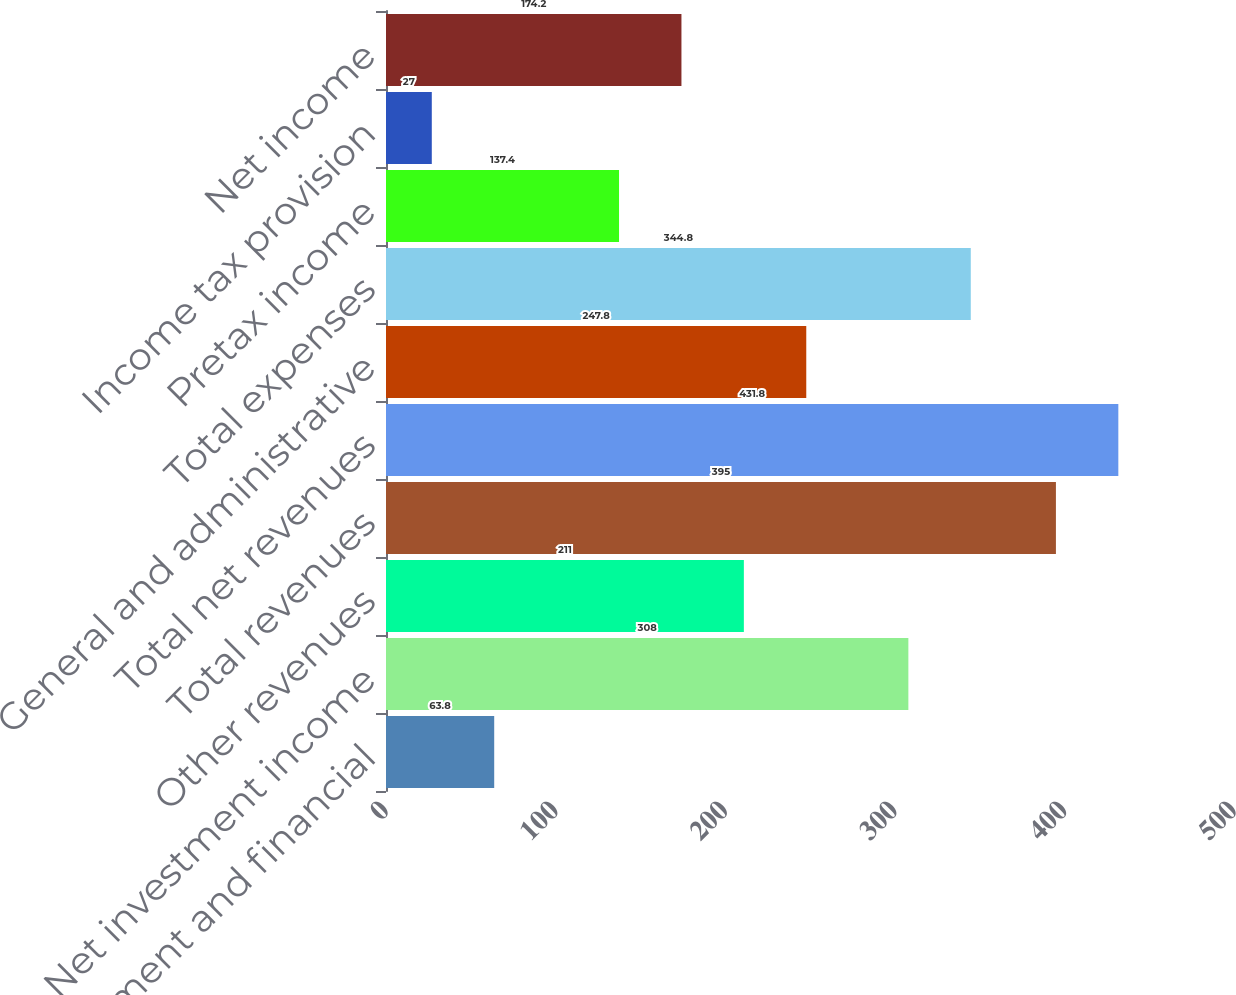Convert chart. <chart><loc_0><loc_0><loc_500><loc_500><bar_chart><fcel>Management and financial<fcel>Net investment income<fcel>Other revenues<fcel>Total revenues<fcel>Total net revenues<fcel>General and administrative<fcel>Total expenses<fcel>Pretax income<fcel>Income tax provision<fcel>Net income<nl><fcel>63.8<fcel>308<fcel>211<fcel>395<fcel>431.8<fcel>247.8<fcel>344.8<fcel>137.4<fcel>27<fcel>174.2<nl></chart> 